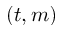<formula> <loc_0><loc_0><loc_500><loc_500>( t , m )</formula> 